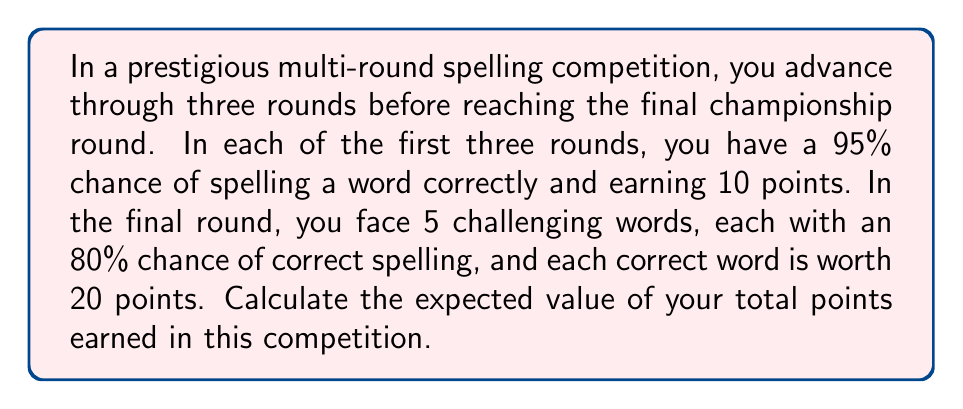Give your solution to this math problem. Let's break this down step-by-step:

1) For the first three rounds:
   - Probability of spelling correctly: $p = 0.95$
   - Points for correct spelling: 10
   - Expected value for each round: $E = 10 \cdot 0.95 = 9.5$ points

2) Total expected value for the first three rounds:
   $E_{1-3} = 3 \cdot 9.5 = 28.5$ points

3) For the final round:
   - Probability of spelling correctly: $p = 0.80$
   - Points for correct spelling: 20
   - Number of words: 5
   - Expected value for each word: $E = 20 \cdot 0.80 = 16$ points
   - Expected value for final round: $E_f = 5 \cdot 16 = 80$ points

4) Total expected value for the entire competition:
   $E_{total} = E_{1-3} + E_f = 28.5 + 80 = 108.5$ points

Therefore, the expected value of the total points earned in this competition is 108.5 points.
Answer: 108.5 points 